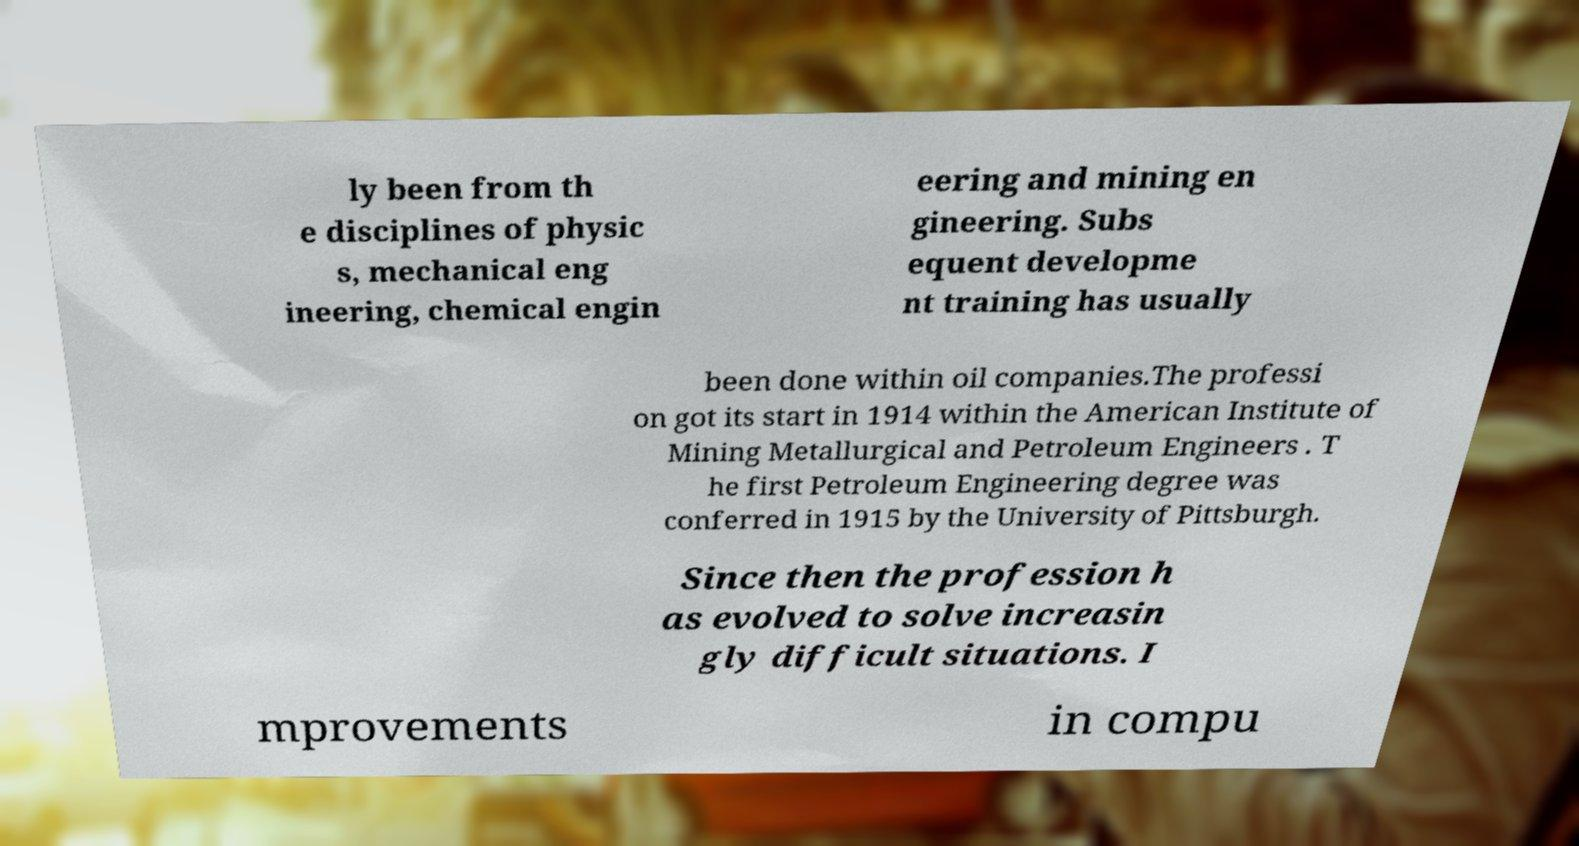Could you assist in decoding the text presented in this image and type it out clearly? ly been from th e disciplines of physic s, mechanical eng ineering, chemical engin eering and mining en gineering. Subs equent developme nt training has usually been done within oil companies.The professi on got its start in 1914 within the American Institute of Mining Metallurgical and Petroleum Engineers . T he first Petroleum Engineering degree was conferred in 1915 by the University of Pittsburgh. Since then the profession h as evolved to solve increasin gly difficult situations. I mprovements in compu 